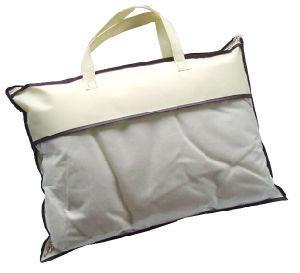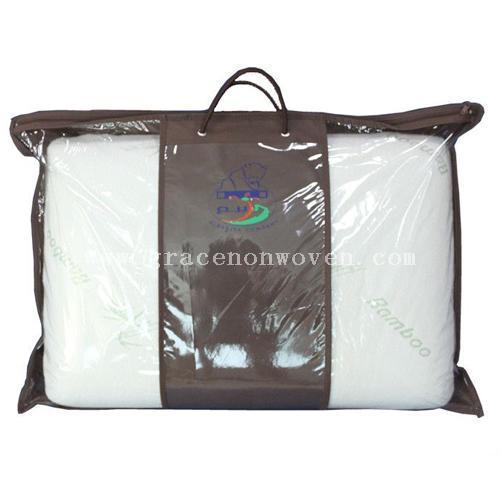The first image is the image on the left, the second image is the image on the right. Analyze the images presented: Is the assertion "The purse in the left image is predominately blue." valid? Answer yes or no. No. The first image is the image on the left, the second image is the image on the right. Considering the images on both sides, is "The bags in the left and right images are displayed in the same position." valid? Answer yes or no. No. 